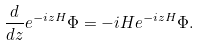Convert formula to latex. <formula><loc_0><loc_0><loc_500><loc_500>\frac { d } { d z } e ^ { - i z H } \Phi = - i H e ^ { - i z H } \Phi .</formula> 